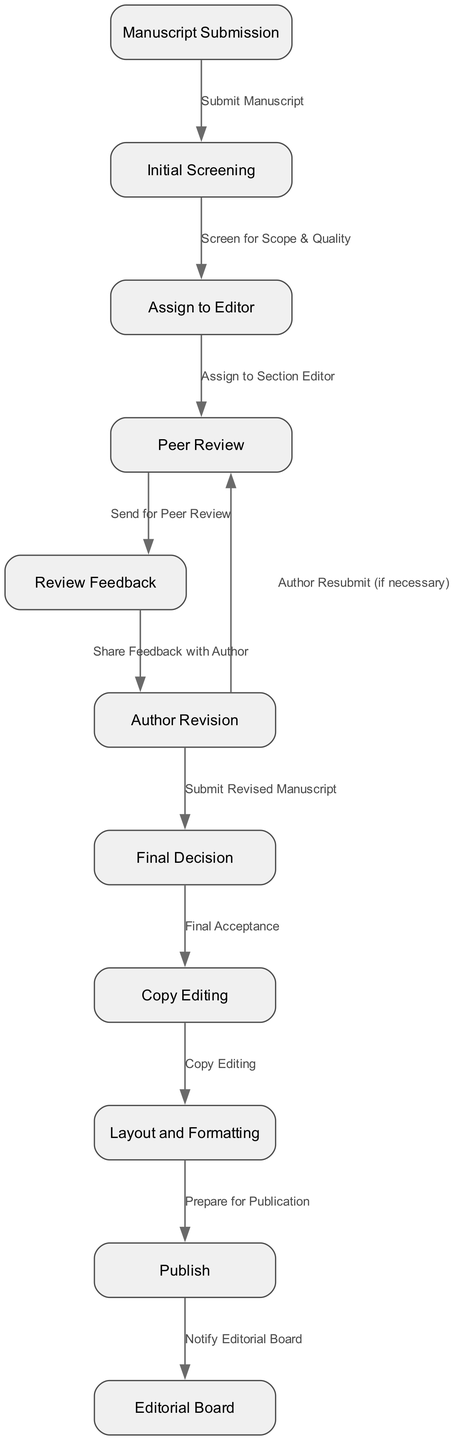What is the first step in the manuscript submission process? The first step is "Manuscript Submission," as indicated by the first node in the diagram.
Answer: Manuscript Submission How many nodes are in the diagram? Counting all the nodes listed in the diagram, there are 11 nodes, which represent different steps in the workflow.
Answer: 11 What is the relationship between "Initial Screening" and "Assign to Editor"? The relationship is that after the "Initial Screening," the process moves forward to "Assign to Editor," as indicated by the directed edge from node 2 to node 3.
Answer: Assign to Editor What step follows "Peer Review"? The step that follows "Peer Review" is "Review Feedback," indicated by the directed edge from node 4 to node 5.
Answer: Review Feedback What happens if authors need to make revisions? If authors need to make revisions, they will "Author Resubmit (if necessary)," indicated by the directed edge from node 6 back to node 4.
Answer: Author Resubmit What is the final step in the manuscript process before notifying the editorial board? The final step before notifying the editorial board is "Publish," which is represented as the last action in the sequence of nodes.
Answer: Publish Which step comes immediately after "Author Revision"? The step that comes immediately after "Author Revision" is "Final Decision," as represented in the directed edge from node 6 to node 7.
Answer: Final Decision How many edges are there connecting the nodes in the diagram? There are 10 edges connecting the nodes based on the relationships defined in the diagram.
Answer: 10 Which node represents the stage where authors share feedback with them? The node representing the stage where feedback is shared with authors is "Review Feedback," which is node 5 in the diagram.
Answer: Review Feedback 